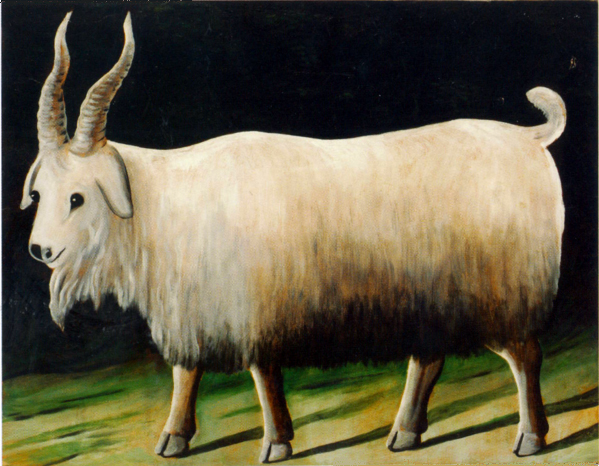What might have inspired the artist to portray the goat in such a manner? The artist might have been inspired by a desire to capture the noble and serene qualities of the goat, emphasizing its majestic horns and calm demeanor. Possibly, the painting seeks to elevate the everyday image of a goat to a more venerable and admirable status, exploring themes of dignity and beauty in common creatures. 